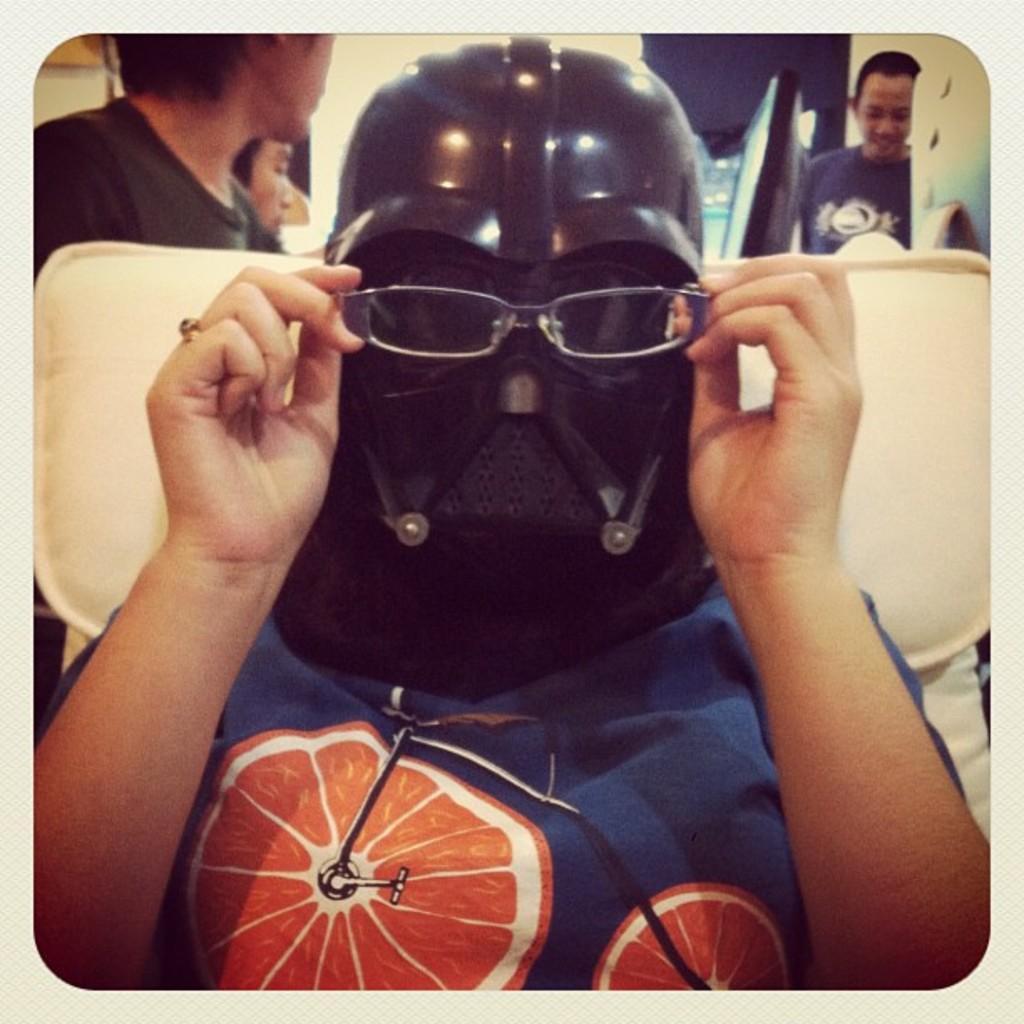Please provide a concise description of this image. In the picture I can see people among them the person in the front is wearing a helmet and holding spectacles in hands. In the background I can see some other objects. 